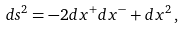<formula> <loc_0><loc_0><loc_500><loc_500>d s ^ { 2 } = - 2 d x ^ { + } d x ^ { - } + d x ^ { 2 } \, ,</formula> 